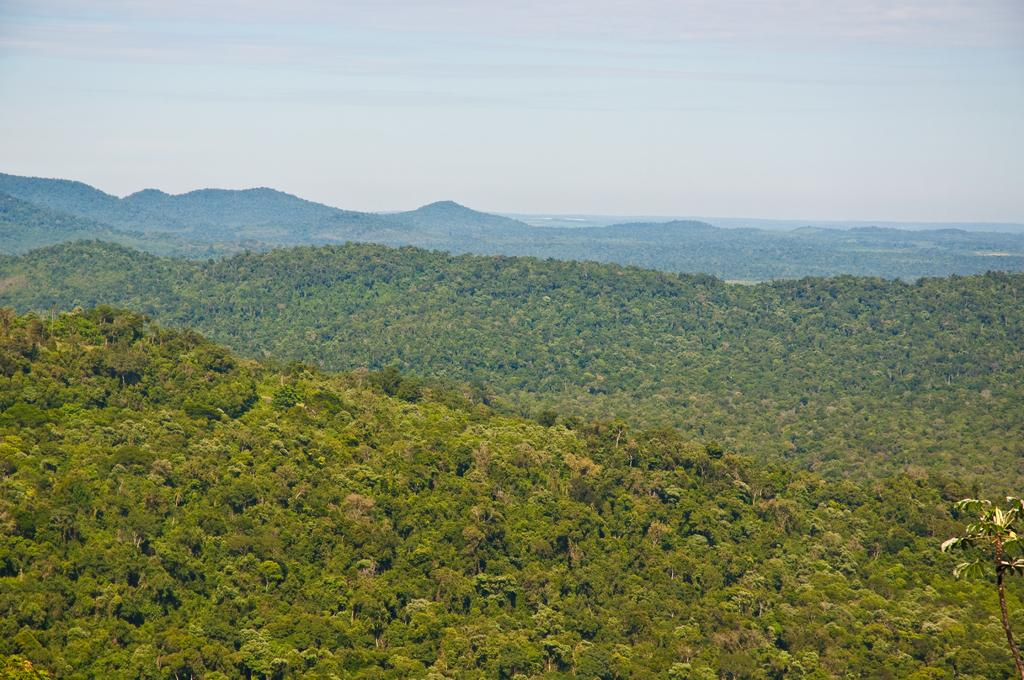What type of natural elements can be seen in the image? There are trees and mountains in the image. What is visible in the background of the image? The sky is visible in the background of the image. Who is the owner of the needle in the image? There is no needle present in the image, so it is not possible to determine the owner. 